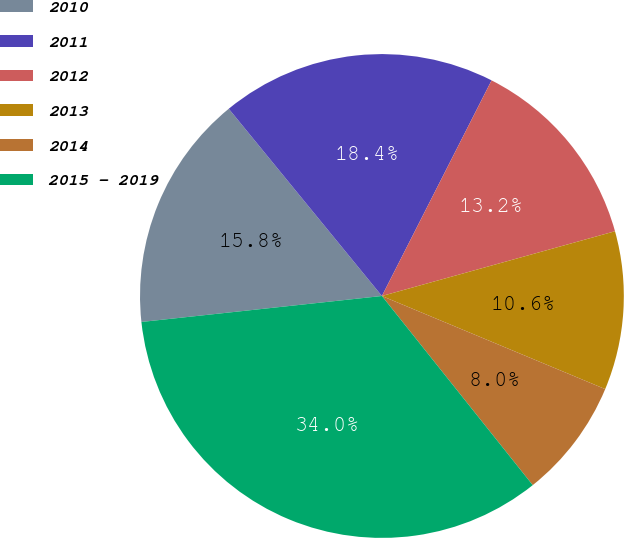Convert chart. <chart><loc_0><loc_0><loc_500><loc_500><pie_chart><fcel>2010<fcel>2011<fcel>2012<fcel>2013<fcel>2014<fcel>2015 - 2019<nl><fcel>15.8%<fcel>18.4%<fcel>13.2%<fcel>10.6%<fcel>8.0%<fcel>34.0%<nl></chart> 